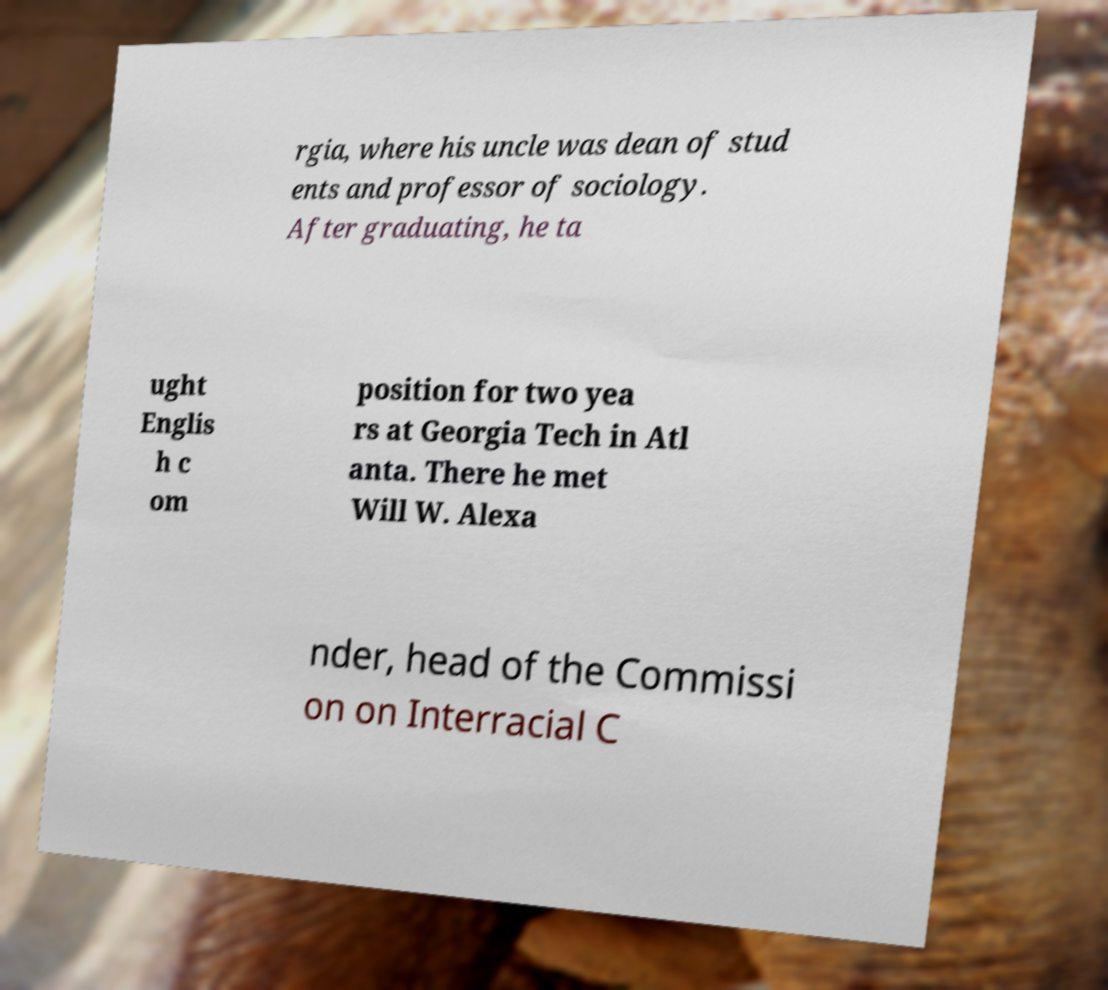There's text embedded in this image that I need extracted. Can you transcribe it verbatim? rgia, where his uncle was dean of stud ents and professor of sociology. After graduating, he ta ught Englis h c om position for two yea rs at Georgia Tech in Atl anta. There he met Will W. Alexa nder, head of the Commissi on on Interracial C 